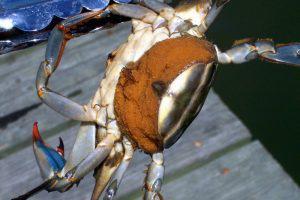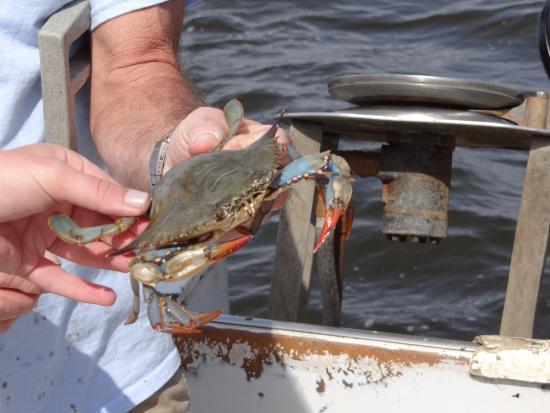The first image is the image on the left, the second image is the image on the right. Given the left and right images, does the statement "The left image features one hand holding a forward-facing crab in front of a body of water." hold true? Answer yes or no. No. The first image is the image on the left, the second image is the image on the right. Given the left and right images, does the statement "Someone is holding the crab in the image on the right." hold true? Answer yes or no. Yes. 